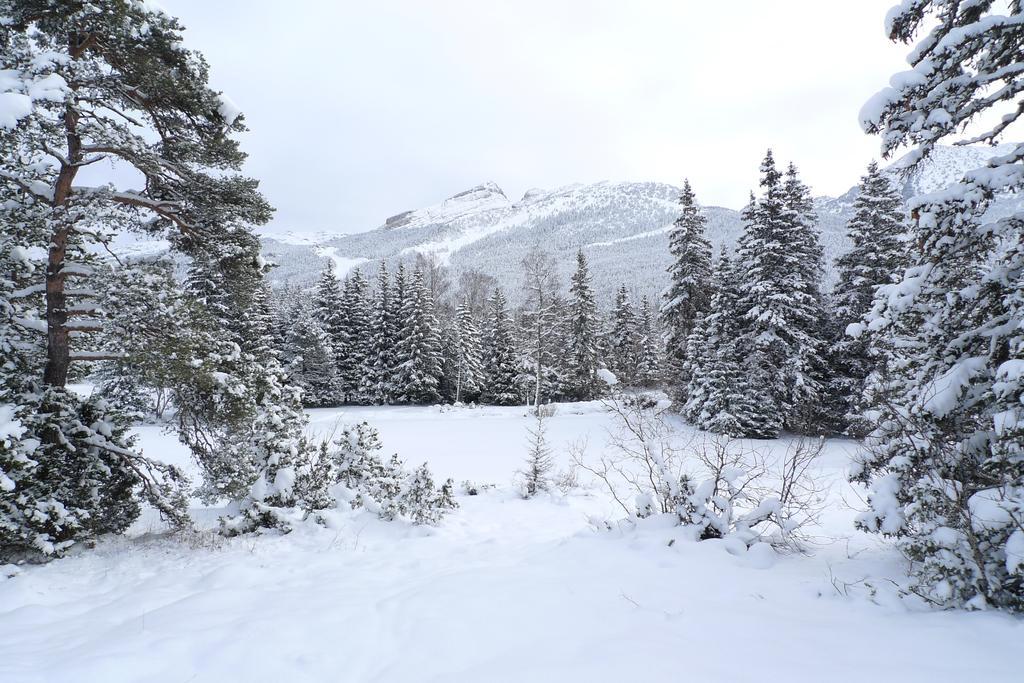Describe this image in one or two sentences. In this image there is a land and trees are covered with snow, in the background there a mountain. 